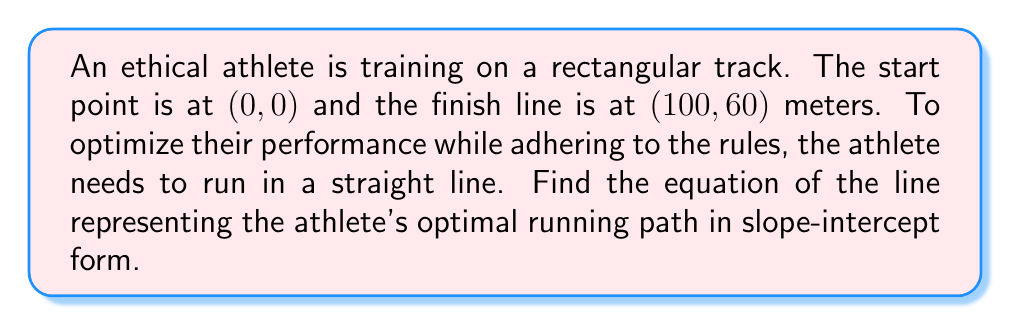Give your solution to this math problem. Let's approach this step-by-step:

1) The line passes through two points: $(0, 0)$ and $(100, 60)$.

2) We can use the point-slope form of a line to find the equation:
   $y - y_1 = m(x - x_1)$

3) First, we need to calculate the slope $m$:
   $m = \frac{y_2 - y_1}{x_2 - x_1} = \frac{60 - 0}{100 - 0} = \frac{60}{100} = \frac{3}{5} = 0.6$

4) Now we can use the point-slope form with $(0, 0)$ as our known point:
   $y - 0 = \frac{3}{5}(x - 0)$

5) Simplify:
   $y = \frac{3}{5}x$

6) This is already in slope-intercept form $(y = mx + b)$, where $m = \frac{3}{5}$ and $b = 0$.

Therefore, the equation of the line representing the athlete's optimal running path is $y = \frac{3}{5}x$.
Answer: $y = \frac{3}{5}x$ 